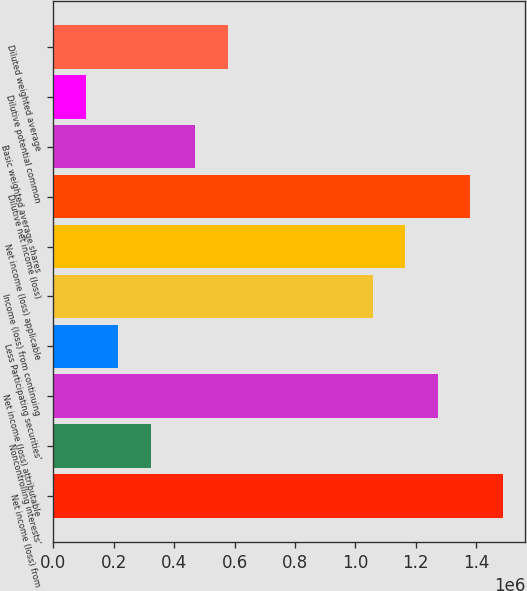Convert chart to OTSL. <chart><loc_0><loc_0><loc_500><loc_500><bar_chart><fcel>Net income (loss) from<fcel>Noncontrolling interests'<fcel>Net income (loss) attributable<fcel>Less Participating securities'<fcel>Income (loss) from continuing<fcel>Net income (loss) applicable<fcel>Dilutive net income (loss)<fcel>Basic weighted average shares<fcel>Dilutive potential common<fcel>Diluted weighted average<nl><fcel>1.48781e+06<fcel>322044<fcel>1.27312e+06<fcel>214697<fcel>1.05842e+06<fcel>1.16577e+06<fcel>1.38047e+06<fcel>470551<fcel>107349<fcel>577898<nl></chart> 